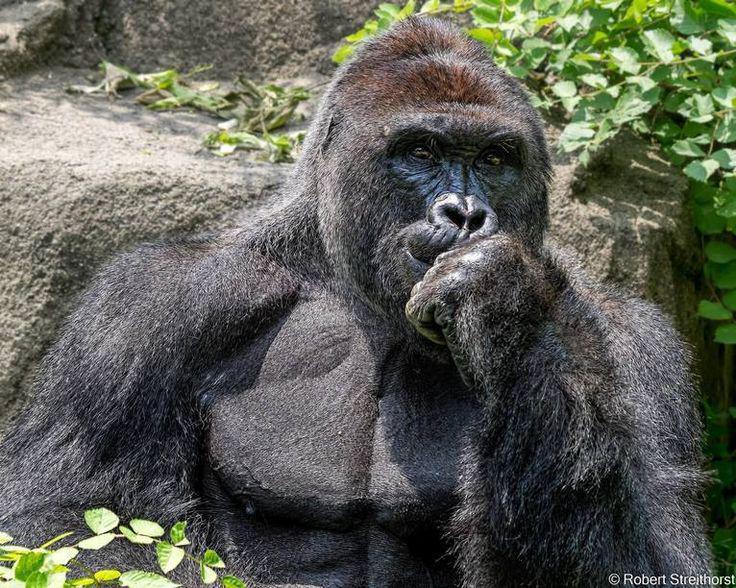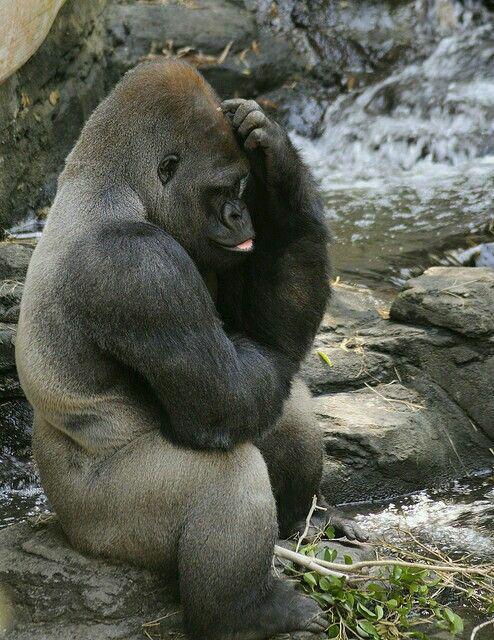The first image is the image on the left, the second image is the image on the right. For the images shown, is this caption "Exactly one of the ape's feet can be seen in the image on the right." true? Answer yes or no. Yes. 